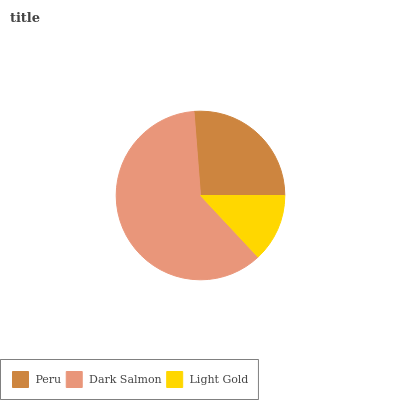Is Light Gold the minimum?
Answer yes or no. Yes. Is Dark Salmon the maximum?
Answer yes or no. Yes. Is Dark Salmon the minimum?
Answer yes or no. No. Is Light Gold the maximum?
Answer yes or no. No. Is Dark Salmon greater than Light Gold?
Answer yes or no. Yes. Is Light Gold less than Dark Salmon?
Answer yes or no. Yes. Is Light Gold greater than Dark Salmon?
Answer yes or no. No. Is Dark Salmon less than Light Gold?
Answer yes or no. No. Is Peru the high median?
Answer yes or no. Yes. Is Peru the low median?
Answer yes or no. Yes. Is Light Gold the high median?
Answer yes or no. No. Is Light Gold the low median?
Answer yes or no. No. 